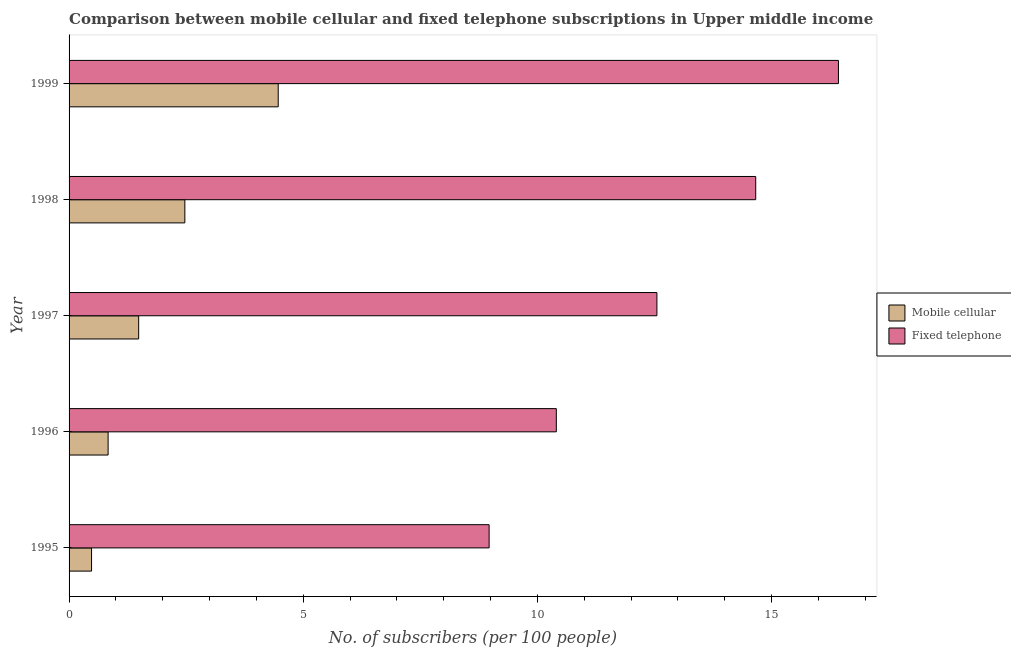How many different coloured bars are there?
Make the answer very short. 2. Are the number of bars on each tick of the Y-axis equal?
Your answer should be compact. Yes. What is the label of the 2nd group of bars from the top?
Provide a short and direct response. 1998. In how many cases, is the number of bars for a given year not equal to the number of legend labels?
Provide a short and direct response. 0. What is the number of fixed telephone subscribers in 1997?
Your response must be concise. 12.55. Across all years, what is the maximum number of mobile cellular subscribers?
Offer a very short reply. 4.47. Across all years, what is the minimum number of fixed telephone subscribers?
Keep it short and to the point. 8.97. In which year was the number of fixed telephone subscribers maximum?
Your answer should be compact. 1999. What is the total number of fixed telephone subscribers in the graph?
Provide a succinct answer. 63.02. What is the difference between the number of fixed telephone subscribers in 1995 and that in 1998?
Your answer should be compact. -5.69. What is the difference between the number of fixed telephone subscribers in 1998 and the number of mobile cellular subscribers in 1996?
Give a very brief answer. 13.83. What is the average number of fixed telephone subscribers per year?
Give a very brief answer. 12.6. In the year 1995, what is the difference between the number of fixed telephone subscribers and number of mobile cellular subscribers?
Offer a terse response. 8.49. In how many years, is the number of mobile cellular subscribers greater than 12 ?
Your answer should be very brief. 0. What is the ratio of the number of mobile cellular subscribers in 1995 to that in 1999?
Provide a short and direct response. 0.11. What is the difference between the highest and the second highest number of fixed telephone subscribers?
Provide a short and direct response. 1.77. What is the difference between the highest and the lowest number of fixed telephone subscribers?
Ensure brevity in your answer.  7.46. What does the 1st bar from the top in 1995 represents?
Offer a terse response. Fixed telephone. What does the 2nd bar from the bottom in 1996 represents?
Ensure brevity in your answer.  Fixed telephone. How many bars are there?
Give a very brief answer. 10. Are all the bars in the graph horizontal?
Your answer should be very brief. Yes. Are the values on the major ticks of X-axis written in scientific E-notation?
Provide a succinct answer. No. Does the graph contain any zero values?
Provide a succinct answer. No. Does the graph contain grids?
Give a very brief answer. No. Where does the legend appear in the graph?
Offer a terse response. Center right. What is the title of the graph?
Offer a terse response. Comparison between mobile cellular and fixed telephone subscriptions in Upper middle income. What is the label or title of the X-axis?
Your answer should be very brief. No. of subscribers (per 100 people). What is the label or title of the Y-axis?
Provide a succinct answer. Year. What is the No. of subscribers (per 100 people) of Mobile cellular in 1995?
Your answer should be very brief. 0.48. What is the No. of subscribers (per 100 people) of Fixed telephone in 1995?
Keep it short and to the point. 8.97. What is the No. of subscribers (per 100 people) in Mobile cellular in 1996?
Provide a short and direct response. 0.83. What is the No. of subscribers (per 100 people) in Fixed telephone in 1996?
Keep it short and to the point. 10.41. What is the No. of subscribers (per 100 people) of Mobile cellular in 1997?
Your answer should be compact. 1.49. What is the No. of subscribers (per 100 people) in Fixed telephone in 1997?
Keep it short and to the point. 12.55. What is the No. of subscribers (per 100 people) in Mobile cellular in 1998?
Make the answer very short. 2.47. What is the No. of subscribers (per 100 people) in Fixed telephone in 1998?
Give a very brief answer. 14.66. What is the No. of subscribers (per 100 people) of Mobile cellular in 1999?
Offer a terse response. 4.47. What is the No. of subscribers (per 100 people) in Fixed telephone in 1999?
Offer a very short reply. 16.43. Across all years, what is the maximum No. of subscribers (per 100 people) of Mobile cellular?
Provide a short and direct response. 4.47. Across all years, what is the maximum No. of subscribers (per 100 people) of Fixed telephone?
Give a very brief answer. 16.43. Across all years, what is the minimum No. of subscribers (per 100 people) in Mobile cellular?
Provide a succinct answer. 0.48. Across all years, what is the minimum No. of subscribers (per 100 people) of Fixed telephone?
Give a very brief answer. 8.97. What is the total No. of subscribers (per 100 people) of Mobile cellular in the graph?
Keep it short and to the point. 9.74. What is the total No. of subscribers (per 100 people) in Fixed telephone in the graph?
Provide a short and direct response. 63.02. What is the difference between the No. of subscribers (per 100 people) in Mobile cellular in 1995 and that in 1996?
Your answer should be very brief. -0.35. What is the difference between the No. of subscribers (per 100 people) of Fixed telephone in 1995 and that in 1996?
Keep it short and to the point. -1.44. What is the difference between the No. of subscribers (per 100 people) of Mobile cellular in 1995 and that in 1997?
Provide a short and direct response. -1.01. What is the difference between the No. of subscribers (per 100 people) of Fixed telephone in 1995 and that in 1997?
Give a very brief answer. -3.58. What is the difference between the No. of subscribers (per 100 people) of Mobile cellular in 1995 and that in 1998?
Your answer should be compact. -1.99. What is the difference between the No. of subscribers (per 100 people) in Fixed telephone in 1995 and that in 1998?
Provide a short and direct response. -5.69. What is the difference between the No. of subscribers (per 100 people) in Mobile cellular in 1995 and that in 1999?
Your answer should be very brief. -3.99. What is the difference between the No. of subscribers (per 100 people) of Fixed telephone in 1995 and that in 1999?
Ensure brevity in your answer.  -7.46. What is the difference between the No. of subscribers (per 100 people) of Mobile cellular in 1996 and that in 1997?
Ensure brevity in your answer.  -0.65. What is the difference between the No. of subscribers (per 100 people) of Fixed telephone in 1996 and that in 1997?
Make the answer very short. -2.15. What is the difference between the No. of subscribers (per 100 people) of Mobile cellular in 1996 and that in 1998?
Keep it short and to the point. -1.64. What is the difference between the No. of subscribers (per 100 people) of Fixed telephone in 1996 and that in 1998?
Offer a very short reply. -4.26. What is the difference between the No. of subscribers (per 100 people) of Mobile cellular in 1996 and that in 1999?
Make the answer very short. -3.63. What is the difference between the No. of subscribers (per 100 people) in Fixed telephone in 1996 and that in 1999?
Provide a succinct answer. -6.02. What is the difference between the No. of subscribers (per 100 people) of Mobile cellular in 1997 and that in 1998?
Offer a terse response. -0.99. What is the difference between the No. of subscribers (per 100 people) in Fixed telephone in 1997 and that in 1998?
Ensure brevity in your answer.  -2.11. What is the difference between the No. of subscribers (per 100 people) in Mobile cellular in 1997 and that in 1999?
Make the answer very short. -2.98. What is the difference between the No. of subscribers (per 100 people) of Fixed telephone in 1997 and that in 1999?
Offer a very short reply. -3.88. What is the difference between the No. of subscribers (per 100 people) in Mobile cellular in 1998 and that in 1999?
Offer a terse response. -1.99. What is the difference between the No. of subscribers (per 100 people) in Fixed telephone in 1998 and that in 1999?
Provide a short and direct response. -1.77. What is the difference between the No. of subscribers (per 100 people) in Mobile cellular in 1995 and the No. of subscribers (per 100 people) in Fixed telephone in 1996?
Offer a terse response. -9.93. What is the difference between the No. of subscribers (per 100 people) in Mobile cellular in 1995 and the No. of subscribers (per 100 people) in Fixed telephone in 1997?
Your answer should be compact. -12.07. What is the difference between the No. of subscribers (per 100 people) of Mobile cellular in 1995 and the No. of subscribers (per 100 people) of Fixed telephone in 1998?
Make the answer very short. -14.18. What is the difference between the No. of subscribers (per 100 people) of Mobile cellular in 1995 and the No. of subscribers (per 100 people) of Fixed telephone in 1999?
Provide a succinct answer. -15.95. What is the difference between the No. of subscribers (per 100 people) of Mobile cellular in 1996 and the No. of subscribers (per 100 people) of Fixed telephone in 1997?
Give a very brief answer. -11.72. What is the difference between the No. of subscribers (per 100 people) in Mobile cellular in 1996 and the No. of subscribers (per 100 people) in Fixed telephone in 1998?
Give a very brief answer. -13.83. What is the difference between the No. of subscribers (per 100 people) in Mobile cellular in 1996 and the No. of subscribers (per 100 people) in Fixed telephone in 1999?
Offer a very short reply. -15.6. What is the difference between the No. of subscribers (per 100 people) of Mobile cellular in 1997 and the No. of subscribers (per 100 people) of Fixed telephone in 1998?
Offer a terse response. -13.18. What is the difference between the No. of subscribers (per 100 people) of Mobile cellular in 1997 and the No. of subscribers (per 100 people) of Fixed telephone in 1999?
Provide a short and direct response. -14.94. What is the difference between the No. of subscribers (per 100 people) in Mobile cellular in 1998 and the No. of subscribers (per 100 people) in Fixed telephone in 1999?
Give a very brief answer. -13.96. What is the average No. of subscribers (per 100 people) of Mobile cellular per year?
Provide a short and direct response. 1.95. What is the average No. of subscribers (per 100 people) in Fixed telephone per year?
Your answer should be compact. 12.6. In the year 1995, what is the difference between the No. of subscribers (per 100 people) in Mobile cellular and No. of subscribers (per 100 people) in Fixed telephone?
Your answer should be compact. -8.49. In the year 1996, what is the difference between the No. of subscribers (per 100 people) of Mobile cellular and No. of subscribers (per 100 people) of Fixed telephone?
Keep it short and to the point. -9.57. In the year 1997, what is the difference between the No. of subscribers (per 100 people) in Mobile cellular and No. of subscribers (per 100 people) in Fixed telephone?
Provide a succinct answer. -11.07. In the year 1998, what is the difference between the No. of subscribers (per 100 people) in Mobile cellular and No. of subscribers (per 100 people) in Fixed telephone?
Give a very brief answer. -12.19. In the year 1999, what is the difference between the No. of subscribers (per 100 people) of Mobile cellular and No. of subscribers (per 100 people) of Fixed telephone?
Your answer should be very brief. -11.96. What is the ratio of the No. of subscribers (per 100 people) in Mobile cellular in 1995 to that in 1996?
Make the answer very short. 0.58. What is the ratio of the No. of subscribers (per 100 people) in Fixed telephone in 1995 to that in 1996?
Offer a terse response. 0.86. What is the ratio of the No. of subscribers (per 100 people) in Mobile cellular in 1995 to that in 1997?
Your answer should be very brief. 0.32. What is the ratio of the No. of subscribers (per 100 people) in Fixed telephone in 1995 to that in 1997?
Give a very brief answer. 0.71. What is the ratio of the No. of subscribers (per 100 people) in Mobile cellular in 1995 to that in 1998?
Your response must be concise. 0.19. What is the ratio of the No. of subscribers (per 100 people) in Fixed telephone in 1995 to that in 1998?
Your response must be concise. 0.61. What is the ratio of the No. of subscribers (per 100 people) of Mobile cellular in 1995 to that in 1999?
Your answer should be compact. 0.11. What is the ratio of the No. of subscribers (per 100 people) of Fixed telephone in 1995 to that in 1999?
Your answer should be very brief. 0.55. What is the ratio of the No. of subscribers (per 100 people) in Mobile cellular in 1996 to that in 1997?
Your answer should be very brief. 0.56. What is the ratio of the No. of subscribers (per 100 people) of Fixed telephone in 1996 to that in 1997?
Provide a short and direct response. 0.83. What is the ratio of the No. of subscribers (per 100 people) of Mobile cellular in 1996 to that in 1998?
Your answer should be compact. 0.34. What is the ratio of the No. of subscribers (per 100 people) of Fixed telephone in 1996 to that in 1998?
Give a very brief answer. 0.71. What is the ratio of the No. of subscribers (per 100 people) in Mobile cellular in 1996 to that in 1999?
Give a very brief answer. 0.19. What is the ratio of the No. of subscribers (per 100 people) of Fixed telephone in 1996 to that in 1999?
Your response must be concise. 0.63. What is the ratio of the No. of subscribers (per 100 people) of Mobile cellular in 1997 to that in 1998?
Provide a short and direct response. 0.6. What is the ratio of the No. of subscribers (per 100 people) of Fixed telephone in 1997 to that in 1998?
Keep it short and to the point. 0.86. What is the ratio of the No. of subscribers (per 100 people) in Mobile cellular in 1997 to that in 1999?
Your answer should be compact. 0.33. What is the ratio of the No. of subscribers (per 100 people) of Fixed telephone in 1997 to that in 1999?
Ensure brevity in your answer.  0.76. What is the ratio of the No. of subscribers (per 100 people) in Mobile cellular in 1998 to that in 1999?
Your answer should be compact. 0.55. What is the ratio of the No. of subscribers (per 100 people) of Fixed telephone in 1998 to that in 1999?
Your answer should be very brief. 0.89. What is the difference between the highest and the second highest No. of subscribers (per 100 people) in Mobile cellular?
Your answer should be very brief. 1.99. What is the difference between the highest and the second highest No. of subscribers (per 100 people) in Fixed telephone?
Provide a short and direct response. 1.77. What is the difference between the highest and the lowest No. of subscribers (per 100 people) of Mobile cellular?
Provide a succinct answer. 3.99. What is the difference between the highest and the lowest No. of subscribers (per 100 people) of Fixed telephone?
Provide a succinct answer. 7.46. 